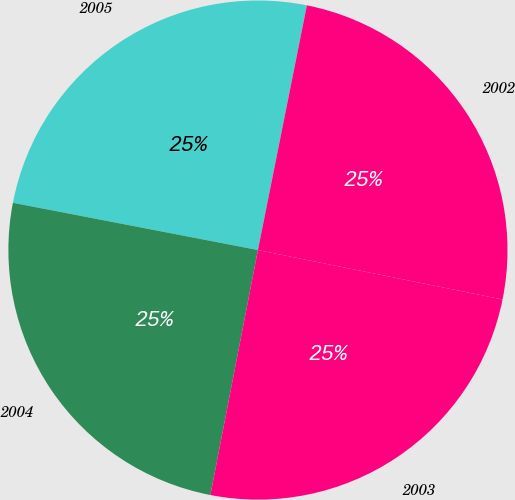Convert chart to OTSL. <chart><loc_0><loc_0><loc_500><loc_500><pie_chart><fcel>2005<fcel>2004<fcel>2003<fcel>2002<nl><fcel>25.11%<fcel>24.98%<fcel>24.88%<fcel>25.03%<nl></chart> 